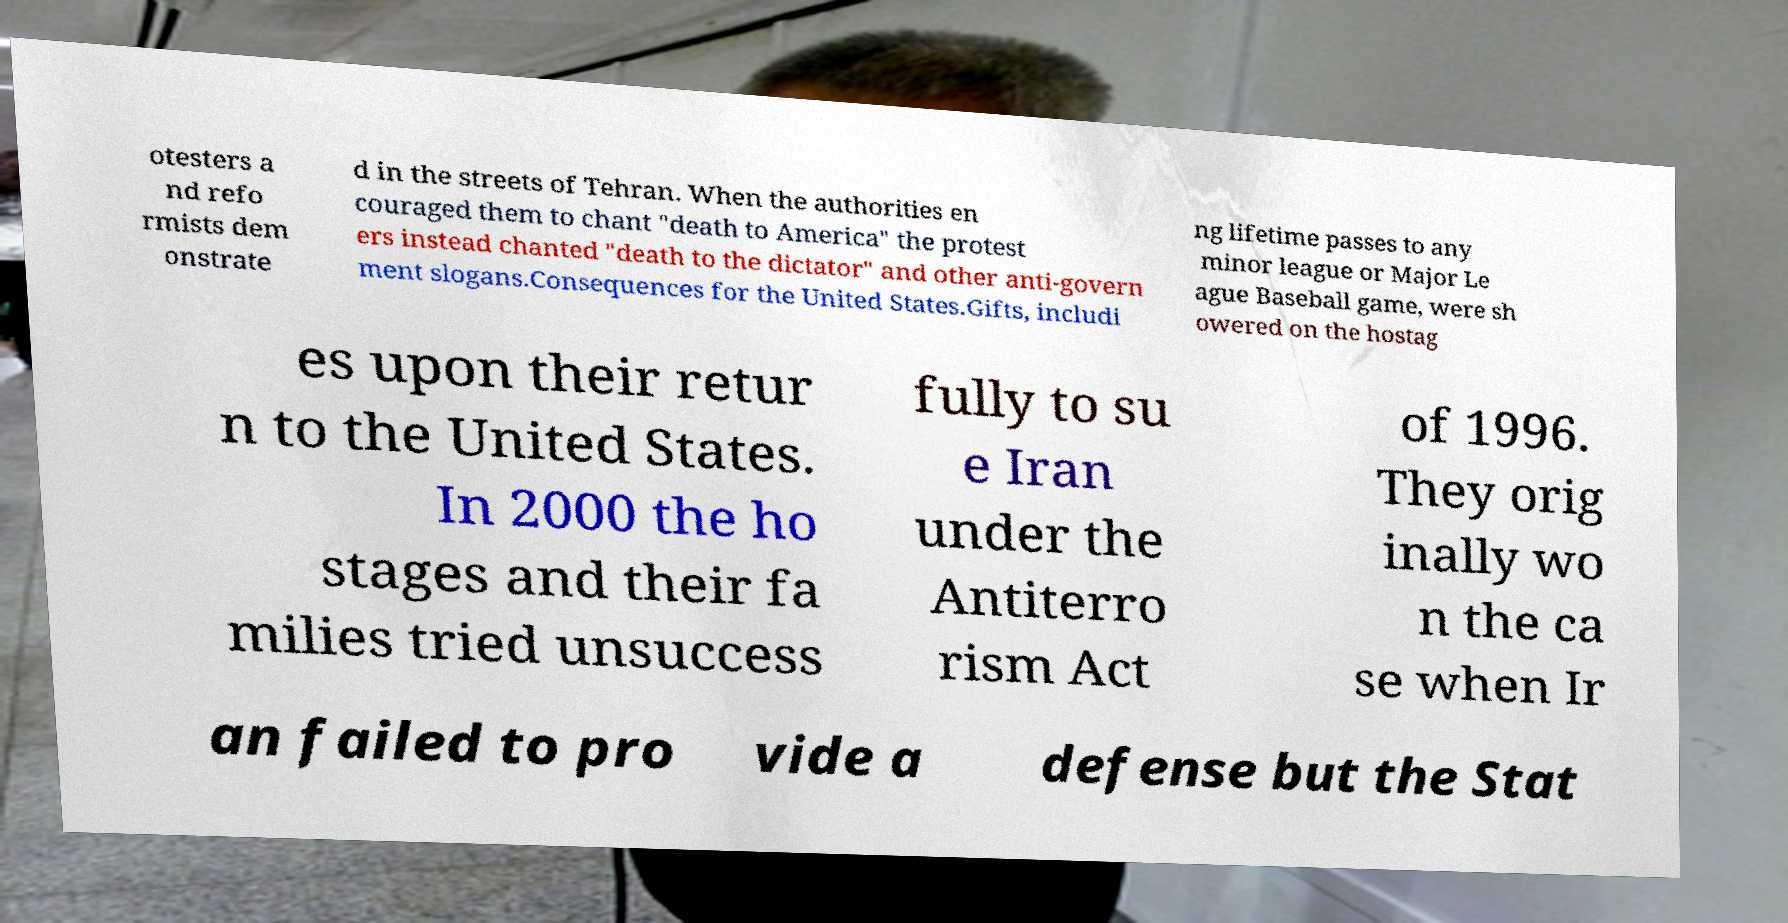Can you accurately transcribe the text from the provided image for me? otesters a nd refo rmists dem onstrate d in the streets of Tehran. When the authorities en couraged them to chant "death to America" the protest ers instead chanted "death to the dictator" and other anti-govern ment slogans.Consequences for the United States.Gifts, includi ng lifetime passes to any minor league or Major Le ague Baseball game, were sh owered on the hostag es upon their retur n to the United States. In 2000 the ho stages and their fa milies tried unsuccess fully to su e Iran under the Antiterro rism Act of 1996. They orig inally wo n the ca se when Ir an failed to pro vide a defense but the Stat 